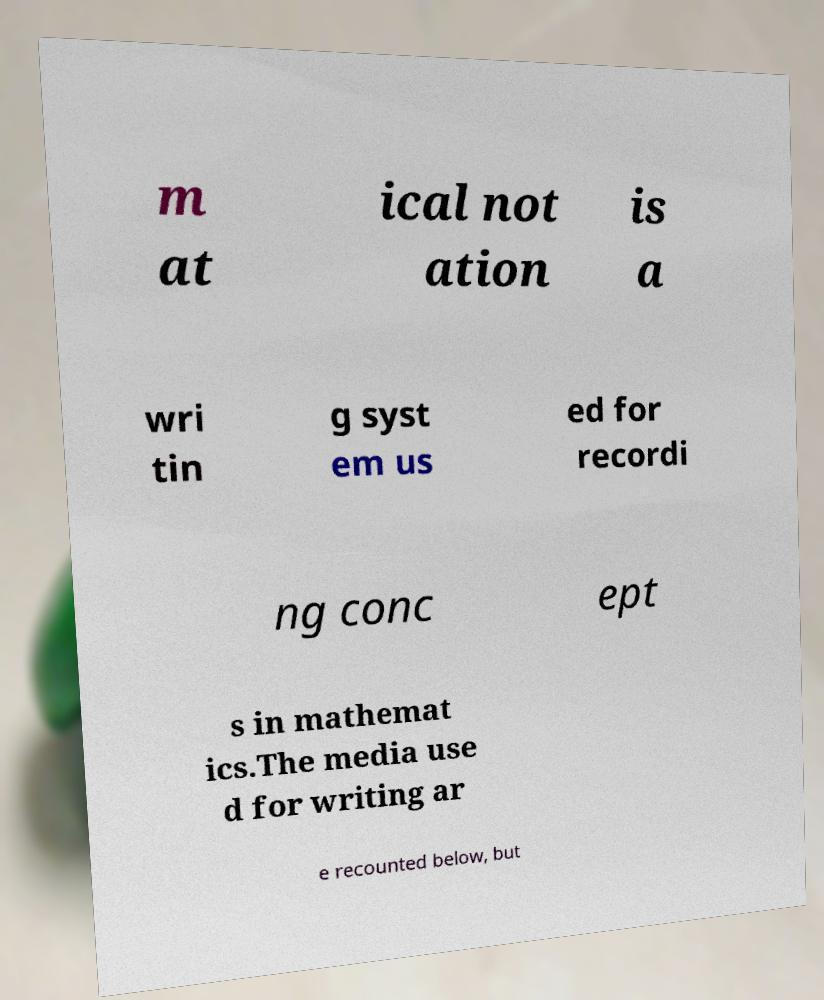Can you read and provide the text displayed in the image?This photo seems to have some interesting text. Can you extract and type it out for me? m at ical not ation is a wri tin g syst em us ed for recordi ng conc ept s in mathemat ics.The media use d for writing ar e recounted below, but 